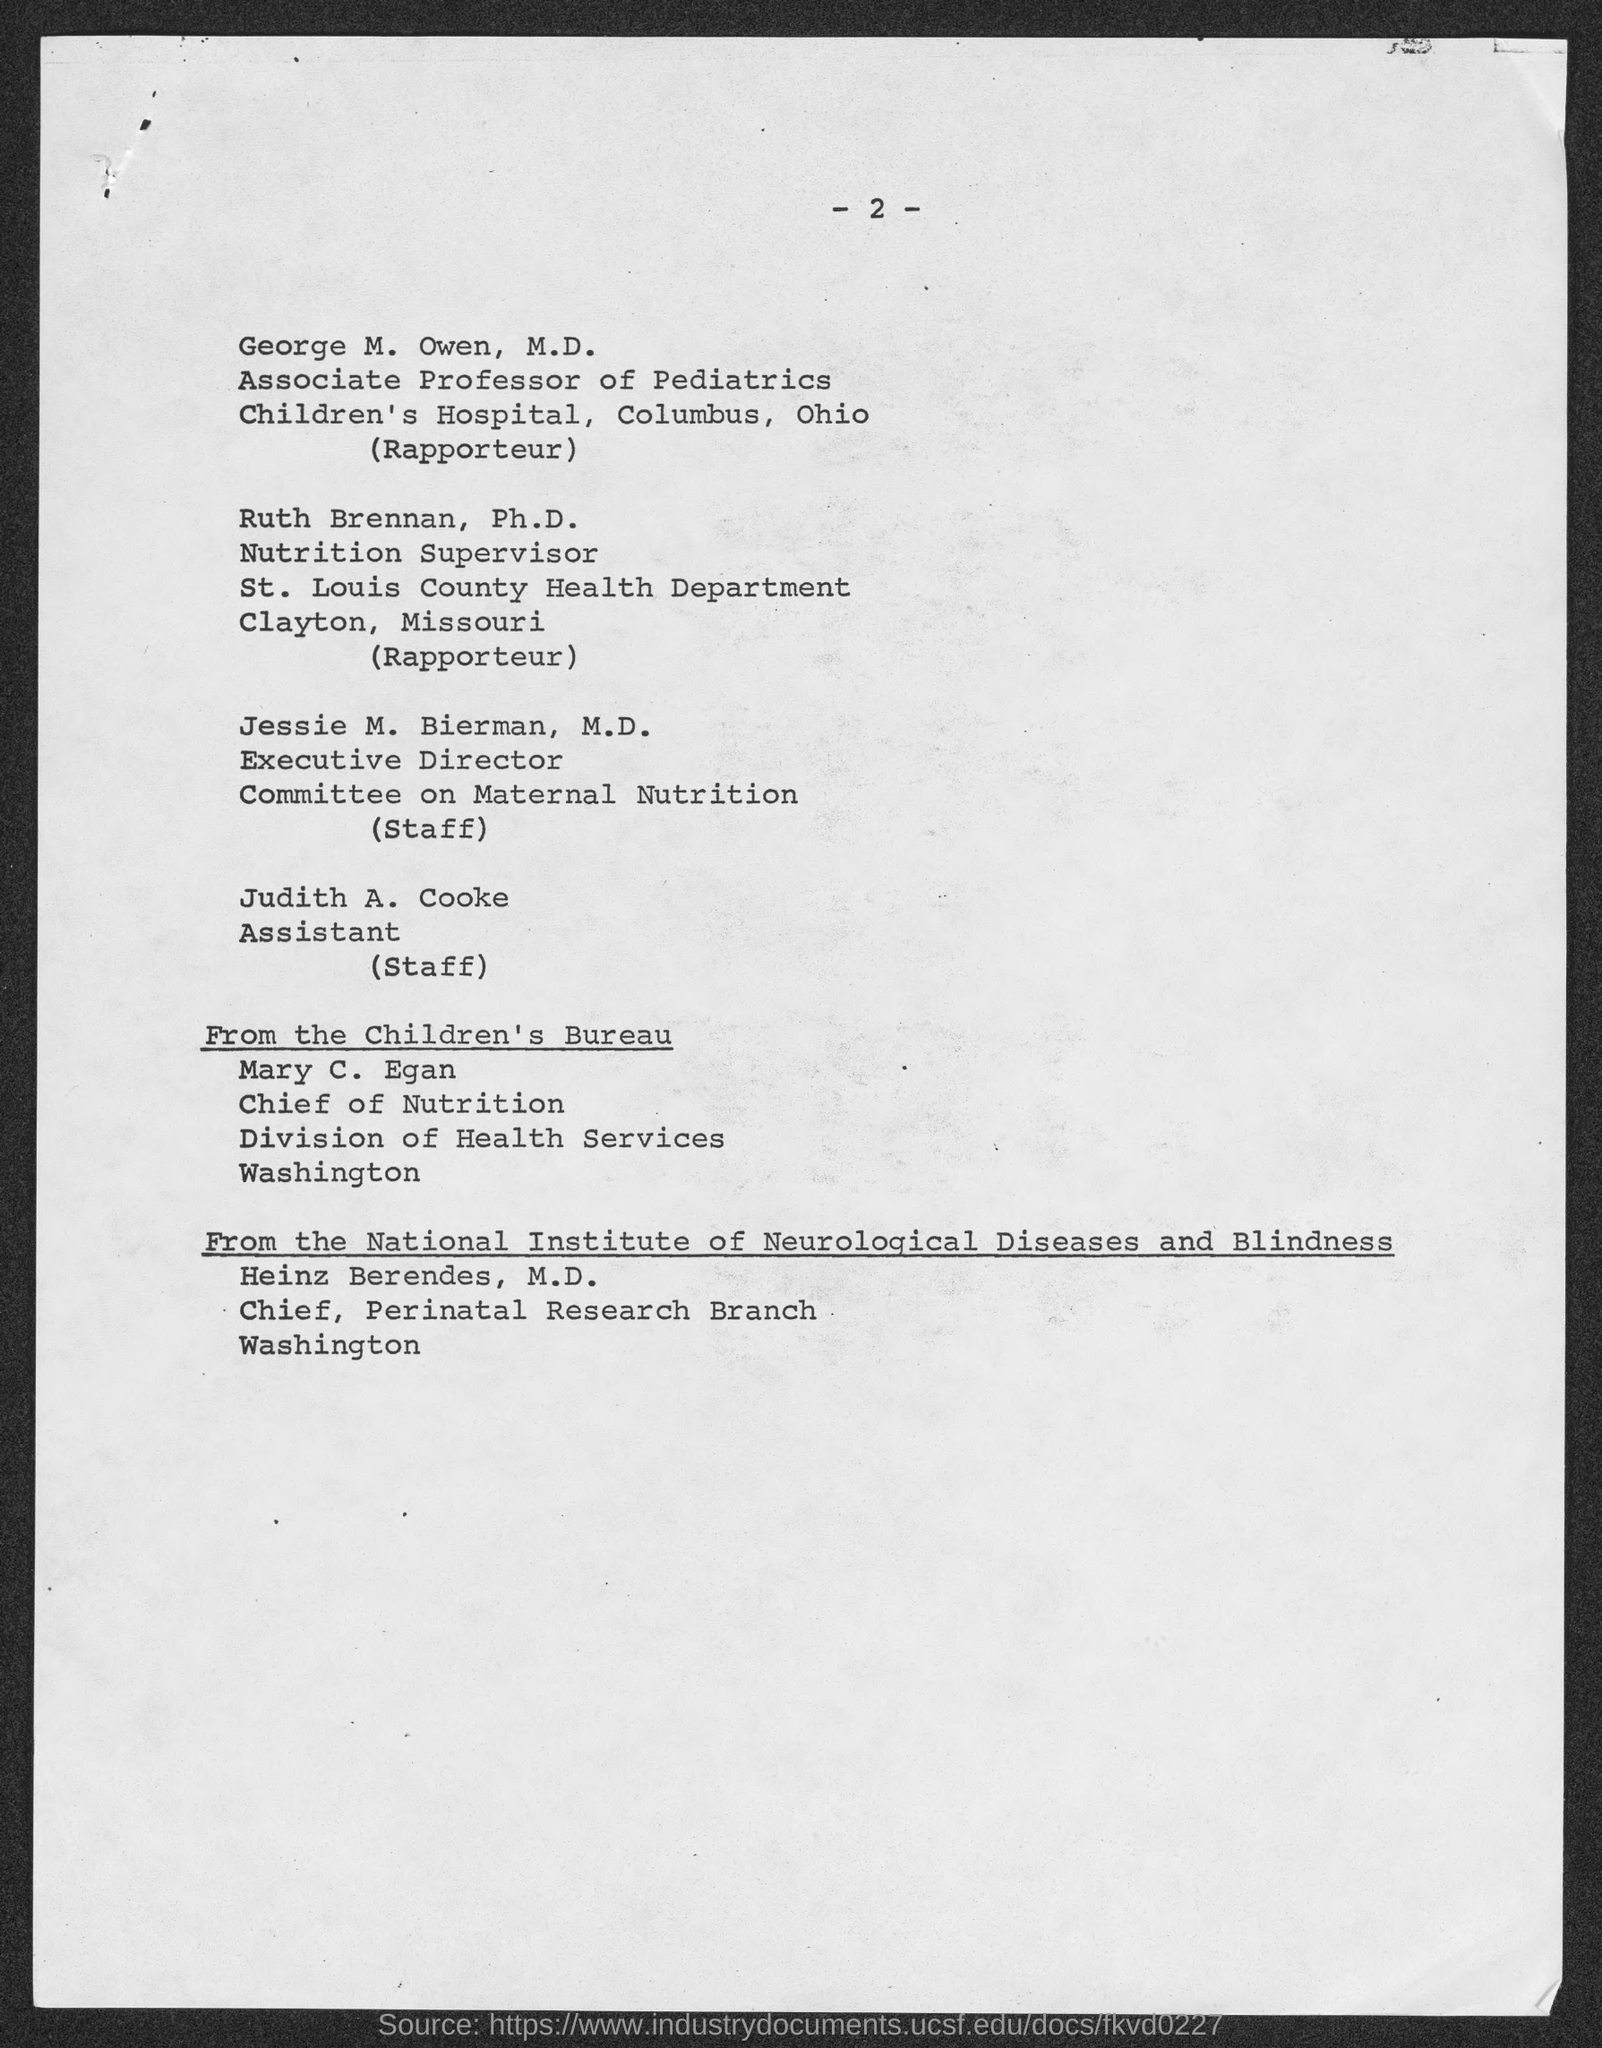What is the page number?
Provide a succinct answer. 2. Who is the assistant?
Offer a terse response. Judith A. Cooke. Who is the chief of nutrition at the division of health services, Washington?
Provide a succinct answer. Mary c. egan. Who is the chief at the perinatal research branch, Washington?
Offer a very short reply. Heinz Berendes, M.D. Who is the executive director of the committee on maternal nutrition?
Offer a terse response. Jessie M. Bierman, M.D. 